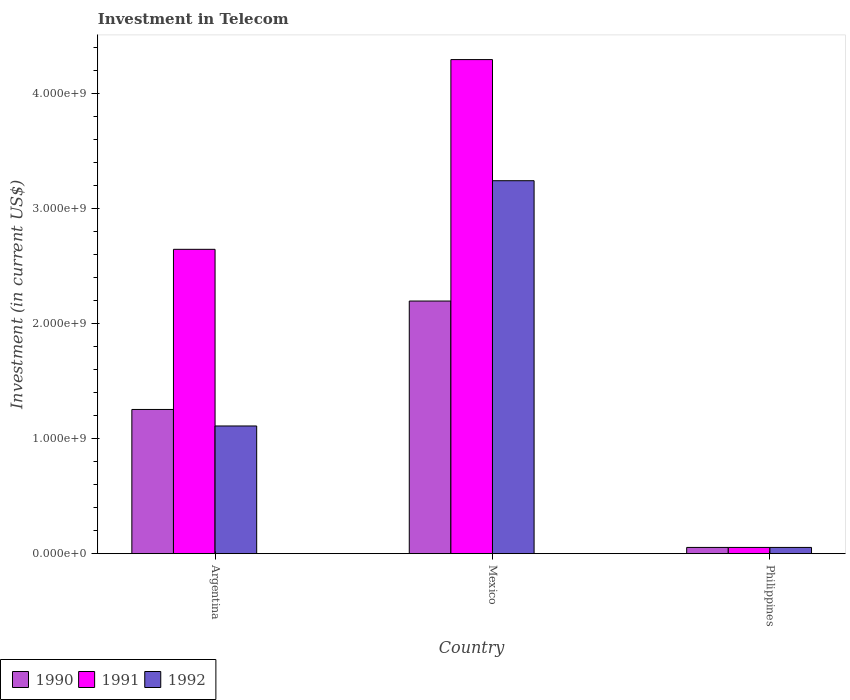How many different coloured bars are there?
Your response must be concise. 3. How many groups of bars are there?
Provide a short and direct response. 3. Are the number of bars per tick equal to the number of legend labels?
Provide a short and direct response. Yes. How many bars are there on the 3rd tick from the right?
Provide a succinct answer. 3. What is the label of the 3rd group of bars from the left?
Ensure brevity in your answer.  Philippines. In how many cases, is the number of bars for a given country not equal to the number of legend labels?
Provide a short and direct response. 0. What is the amount invested in telecom in 1990 in Argentina?
Give a very brief answer. 1.25e+09. Across all countries, what is the maximum amount invested in telecom in 1990?
Ensure brevity in your answer.  2.20e+09. Across all countries, what is the minimum amount invested in telecom in 1992?
Keep it short and to the point. 5.42e+07. What is the total amount invested in telecom in 1992 in the graph?
Give a very brief answer. 4.41e+09. What is the difference between the amount invested in telecom in 1990 in Argentina and that in Mexico?
Make the answer very short. -9.43e+08. What is the difference between the amount invested in telecom in 1992 in Mexico and the amount invested in telecom in 1990 in Argentina?
Provide a succinct answer. 1.99e+09. What is the average amount invested in telecom in 1991 per country?
Ensure brevity in your answer.  2.33e+09. In how many countries, is the amount invested in telecom in 1990 greater than 2400000000 US$?
Your response must be concise. 0. What is the ratio of the amount invested in telecom in 1992 in Argentina to that in Mexico?
Provide a succinct answer. 0.34. Is the amount invested in telecom in 1990 in Argentina less than that in Philippines?
Your answer should be very brief. No. Is the difference between the amount invested in telecom in 1991 in Argentina and Philippines greater than the difference between the amount invested in telecom in 1992 in Argentina and Philippines?
Give a very brief answer. Yes. What is the difference between the highest and the second highest amount invested in telecom in 1992?
Provide a short and direct response. 3.19e+09. What is the difference between the highest and the lowest amount invested in telecom in 1990?
Make the answer very short. 2.14e+09. What does the 1st bar from the left in Argentina represents?
Your response must be concise. 1990. What does the 3rd bar from the right in Argentina represents?
Your response must be concise. 1990. Are all the bars in the graph horizontal?
Make the answer very short. No. How many countries are there in the graph?
Offer a very short reply. 3. What is the difference between two consecutive major ticks on the Y-axis?
Provide a short and direct response. 1.00e+09. Does the graph contain any zero values?
Your answer should be compact. No. Does the graph contain grids?
Your response must be concise. No. How many legend labels are there?
Offer a very short reply. 3. How are the legend labels stacked?
Give a very brief answer. Horizontal. What is the title of the graph?
Offer a terse response. Investment in Telecom. Does "2012" appear as one of the legend labels in the graph?
Your answer should be very brief. No. What is the label or title of the Y-axis?
Provide a succinct answer. Investment (in current US$). What is the Investment (in current US$) of 1990 in Argentina?
Provide a succinct answer. 1.25e+09. What is the Investment (in current US$) in 1991 in Argentina?
Provide a short and direct response. 2.65e+09. What is the Investment (in current US$) of 1992 in Argentina?
Your answer should be compact. 1.11e+09. What is the Investment (in current US$) of 1990 in Mexico?
Offer a terse response. 2.20e+09. What is the Investment (in current US$) of 1991 in Mexico?
Your answer should be compact. 4.30e+09. What is the Investment (in current US$) of 1992 in Mexico?
Make the answer very short. 3.24e+09. What is the Investment (in current US$) of 1990 in Philippines?
Give a very brief answer. 5.42e+07. What is the Investment (in current US$) of 1991 in Philippines?
Make the answer very short. 5.42e+07. What is the Investment (in current US$) in 1992 in Philippines?
Give a very brief answer. 5.42e+07. Across all countries, what is the maximum Investment (in current US$) in 1990?
Your answer should be very brief. 2.20e+09. Across all countries, what is the maximum Investment (in current US$) in 1991?
Give a very brief answer. 4.30e+09. Across all countries, what is the maximum Investment (in current US$) in 1992?
Ensure brevity in your answer.  3.24e+09. Across all countries, what is the minimum Investment (in current US$) of 1990?
Offer a very short reply. 5.42e+07. Across all countries, what is the minimum Investment (in current US$) of 1991?
Offer a terse response. 5.42e+07. Across all countries, what is the minimum Investment (in current US$) of 1992?
Your answer should be compact. 5.42e+07. What is the total Investment (in current US$) in 1990 in the graph?
Your answer should be very brief. 3.51e+09. What is the total Investment (in current US$) in 1991 in the graph?
Offer a terse response. 7.00e+09. What is the total Investment (in current US$) in 1992 in the graph?
Your answer should be very brief. 4.41e+09. What is the difference between the Investment (in current US$) in 1990 in Argentina and that in Mexico?
Make the answer very short. -9.43e+08. What is the difference between the Investment (in current US$) in 1991 in Argentina and that in Mexico?
Your answer should be compact. -1.65e+09. What is the difference between the Investment (in current US$) of 1992 in Argentina and that in Mexico?
Provide a succinct answer. -2.13e+09. What is the difference between the Investment (in current US$) of 1990 in Argentina and that in Philippines?
Provide a short and direct response. 1.20e+09. What is the difference between the Investment (in current US$) of 1991 in Argentina and that in Philippines?
Provide a short and direct response. 2.59e+09. What is the difference between the Investment (in current US$) in 1992 in Argentina and that in Philippines?
Keep it short and to the point. 1.06e+09. What is the difference between the Investment (in current US$) of 1990 in Mexico and that in Philippines?
Provide a succinct answer. 2.14e+09. What is the difference between the Investment (in current US$) of 1991 in Mexico and that in Philippines?
Offer a very short reply. 4.24e+09. What is the difference between the Investment (in current US$) of 1992 in Mexico and that in Philippines?
Provide a short and direct response. 3.19e+09. What is the difference between the Investment (in current US$) of 1990 in Argentina and the Investment (in current US$) of 1991 in Mexico?
Your answer should be very brief. -3.04e+09. What is the difference between the Investment (in current US$) of 1990 in Argentina and the Investment (in current US$) of 1992 in Mexico?
Provide a short and direct response. -1.99e+09. What is the difference between the Investment (in current US$) in 1991 in Argentina and the Investment (in current US$) in 1992 in Mexico?
Provide a short and direct response. -5.97e+08. What is the difference between the Investment (in current US$) of 1990 in Argentina and the Investment (in current US$) of 1991 in Philippines?
Ensure brevity in your answer.  1.20e+09. What is the difference between the Investment (in current US$) in 1990 in Argentina and the Investment (in current US$) in 1992 in Philippines?
Offer a terse response. 1.20e+09. What is the difference between the Investment (in current US$) in 1991 in Argentina and the Investment (in current US$) in 1992 in Philippines?
Provide a short and direct response. 2.59e+09. What is the difference between the Investment (in current US$) of 1990 in Mexico and the Investment (in current US$) of 1991 in Philippines?
Your answer should be compact. 2.14e+09. What is the difference between the Investment (in current US$) in 1990 in Mexico and the Investment (in current US$) in 1992 in Philippines?
Give a very brief answer. 2.14e+09. What is the difference between the Investment (in current US$) of 1991 in Mexico and the Investment (in current US$) of 1992 in Philippines?
Make the answer very short. 4.24e+09. What is the average Investment (in current US$) in 1990 per country?
Offer a very short reply. 1.17e+09. What is the average Investment (in current US$) in 1991 per country?
Offer a terse response. 2.33e+09. What is the average Investment (in current US$) in 1992 per country?
Provide a succinct answer. 1.47e+09. What is the difference between the Investment (in current US$) in 1990 and Investment (in current US$) in 1991 in Argentina?
Offer a terse response. -1.39e+09. What is the difference between the Investment (in current US$) of 1990 and Investment (in current US$) of 1992 in Argentina?
Your answer should be very brief. 1.44e+08. What is the difference between the Investment (in current US$) of 1991 and Investment (in current US$) of 1992 in Argentina?
Your response must be concise. 1.54e+09. What is the difference between the Investment (in current US$) of 1990 and Investment (in current US$) of 1991 in Mexico?
Give a very brief answer. -2.10e+09. What is the difference between the Investment (in current US$) of 1990 and Investment (in current US$) of 1992 in Mexico?
Give a very brief answer. -1.05e+09. What is the difference between the Investment (in current US$) in 1991 and Investment (in current US$) in 1992 in Mexico?
Your answer should be compact. 1.05e+09. What is the difference between the Investment (in current US$) in 1991 and Investment (in current US$) in 1992 in Philippines?
Give a very brief answer. 0. What is the ratio of the Investment (in current US$) of 1990 in Argentina to that in Mexico?
Your answer should be very brief. 0.57. What is the ratio of the Investment (in current US$) of 1991 in Argentina to that in Mexico?
Give a very brief answer. 0.62. What is the ratio of the Investment (in current US$) of 1992 in Argentina to that in Mexico?
Provide a succinct answer. 0.34. What is the ratio of the Investment (in current US$) in 1990 in Argentina to that in Philippines?
Provide a short and direct response. 23.15. What is the ratio of the Investment (in current US$) of 1991 in Argentina to that in Philippines?
Offer a very short reply. 48.86. What is the ratio of the Investment (in current US$) of 1992 in Argentina to that in Philippines?
Ensure brevity in your answer.  20.5. What is the ratio of the Investment (in current US$) of 1990 in Mexico to that in Philippines?
Provide a short and direct response. 40.55. What is the ratio of the Investment (in current US$) of 1991 in Mexico to that in Philippines?
Provide a short and direct response. 79.32. What is the ratio of the Investment (in current US$) of 1992 in Mexico to that in Philippines?
Provide a short and direct response. 59.87. What is the difference between the highest and the second highest Investment (in current US$) in 1990?
Your answer should be compact. 9.43e+08. What is the difference between the highest and the second highest Investment (in current US$) in 1991?
Make the answer very short. 1.65e+09. What is the difference between the highest and the second highest Investment (in current US$) of 1992?
Your answer should be very brief. 2.13e+09. What is the difference between the highest and the lowest Investment (in current US$) in 1990?
Keep it short and to the point. 2.14e+09. What is the difference between the highest and the lowest Investment (in current US$) in 1991?
Offer a very short reply. 4.24e+09. What is the difference between the highest and the lowest Investment (in current US$) in 1992?
Ensure brevity in your answer.  3.19e+09. 